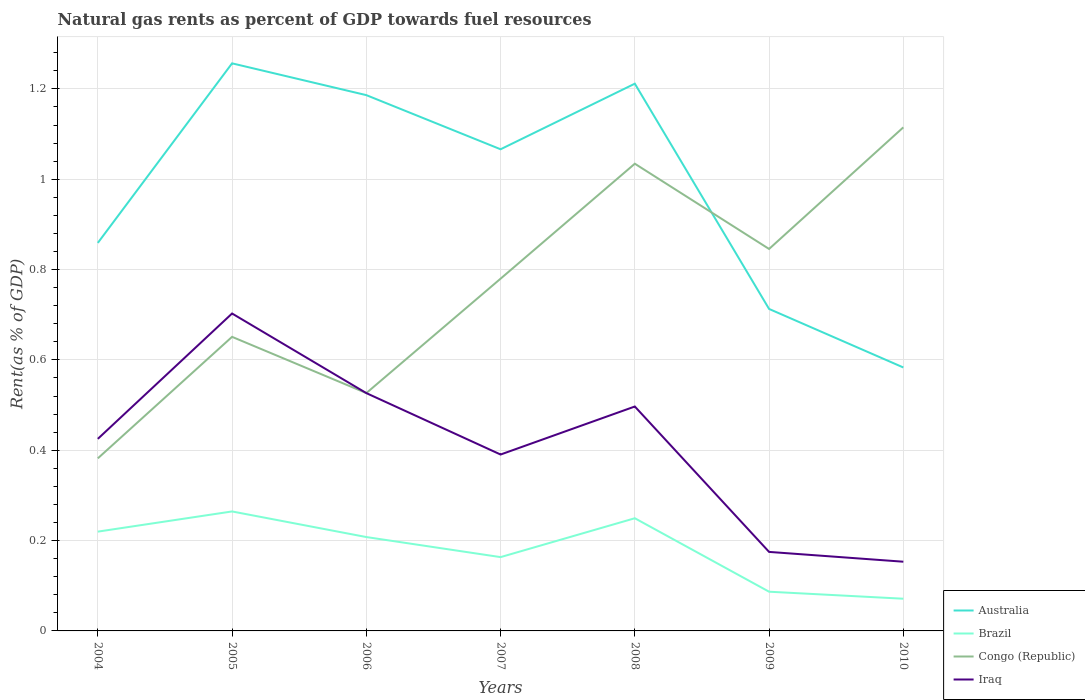Does the line corresponding to Australia intersect with the line corresponding to Congo (Republic)?
Make the answer very short. Yes. Is the number of lines equal to the number of legend labels?
Your answer should be very brief. Yes. Across all years, what is the maximum matural gas rent in Congo (Republic)?
Provide a short and direct response. 0.38. What is the total matural gas rent in Brazil in the graph?
Offer a very short reply. 0.01. What is the difference between the highest and the second highest matural gas rent in Iraq?
Your answer should be very brief. 0.55. What is the difference between the highest and the lowest matural gas rent in Congo (Republic)?
Give a very brief answer. 4. Are the values on the major ticks of Y-axis written in scientific E-notation?
Offer a very short reply. No. Does the graph contain any zero values?
Provide a short and direct response. No. Does the graph contain grids?
Make the answer very short. Yes. What is the title of the graph?
Give a very brief answer. Natural gas rents as percent of GDP towards fuel resources. Does "Liechtenstein" appear as one of the legend labels in the graph?
Make the answer very short. No. What is the label or title of the Y-axis?
Provide a succinct answer. Rent(as % of GDP). What is the Rent(as % of GDP) of Australia in 2004?
Your response must be concise. 0.86. What is the Rent(as % of GDP) in Brazil in 2004?
Keep it short and to the point. 0.22. What is the Rent(as % of GDP) of Congo (Republic) in 2004?
Offer a terse response. 0.38. What is the Rent(as % of GDP) in Iraq in 2004?
Your answer should be very brief. 0.43. What is the Rent(as % of GDP) of Australia in 2005?
Give a very brief answer. 1.26. What is the Rent(as % of GDP) of Brazil in 2005?
Provide a short and direct response. 0.26. What is the Rent(as % of GDP) of Congo (Republic) in 2005?
Give a very brief answer. 0.65. What is the Rent(as % of GDP) in Iraq in 2005?
Make the answer very short. 0.7. What is the Rent(as % of GDP) in Australia in 2006?
Give a very brief answer. 1.19. What is the Rent(as % of GDP) in Brazil in 2006?
Provide a short and direct response. 0.21. What is the Rent(as % of GDP) in Congo (Republic) in 2006?
Ensure brevity in your answer.  0.53. What is the Rent(as % of GDP) in Iraq in 2006?
Provide a succinct answer. 0.53. What is the Rent(as % of GDP) in Australia in 2007?
Provide a short and direct response. 1.07. What is the Rent(as % of GDP) in Brazil in 2007?
Give a very brief answer. 0.16. What is the Rent(as % of GDP) in Congo (Republic) in 2007?
Your answer should be very brief. 0.78. What is the Rent(as % of GDP) of Iraq in 2007?
Keep it short and to the point. 0.39. What is the Rent(as % of GDP) of Australia in 2008?
Ensure brevity in your answer.  1.21. What is the Rent(as % of GDP) in Brazil in 2008?
Offer a terse response. 0.25. What is the Rent(as % of GDP) of Congo (Republic) in 2008?
Your answer should be very brief. 1.03. What is the Rent(as % of GDP) in Iraq in 2008?
Offer a very short reply. 0.5. What is the Rent(as % of GDP) in Australia in 2009?
Your answer should be compact. 0.71. What is the Rent(as % of GDP) of Brazil in 2009?
Give a very brief answer. 0.09. What is the Rent(as % of GDP) in Congo (Republic) in 2009?
Provide a succinct answer. 0.85. What is the Rent(as % of GDP) in Iraq in 2009?
Offer a terse response. 0.17. What is the Rent(as % of GDP) of Australia in 2010?
Your response must be concise. 0.58. What is the Rent(as % of GDP) in Brazil in 2010?
Offer a very short reply. 0.07. What is the Rent(as % of GDP) of Congo (Republic) in 2010?
Keep it short and to the point. 1.11. What is the Rent(as % of GDP) in Iraq in 2010?
Ensure brevity in your answer.  0.15. Across all years, what is the maximum Rent(as % of GDP) of Australia?
Give a very brief answer. 1.26. Across all years, what is the maximum Rent(as % of GDP) of Brazil?
Your response must be concise. 0.26. Across all years, what is the maximum Rent(as % of GDP) of Congo (Republic)?
Your answer should be compact. 1.11. Across all years, what is the maximum Rent(as % of GDP) in Iraq?
Provide a succinct answer. 0.7. Across all years, what is the minimum Rent(as % of GDP) of Australia?
Keep it short and to the point. 0.58. Across all years, what is the minimum Rent(as % of GDP) of Brazil?
Offer a very short reply. 0.07. Across all years, what is the minimum Rent(as % of GDP) of Congo (Republic)?
Give a very brief answer. 0.38. Across all years, what is the minimum Rent(as % of GDP) of Iraq?
Give a very brief answer. 0.15. What is the total Rent(as % of GDP) in Australia in the graph?
Keep it short and to the point. 6.88. What is the total Rent(as % of GDP) of Brazil in the graph?
Keep it short and to the point. 1.26. What is the total Rent(as % of GDP) in Congo (Republic) in the graph?
Give a very brief answer. 5.33. What is the total Rent(as % of GDP) in Iraq in the graph?
Ensure brevity in your answer.  2.87. What is the difference between the Rent(as % of GDP) in Australia in 2004 and that in 2005?
Offer a very short reply. -0.4. What is the difference between the Rent(as % of GDP) in Brazil in 2004 and that in 2005?
Keep it short and to the point. -0.04. What is the difference between the Rent(as % of GDP) in Congo (Republic) in 2004 and that in 2005?
Keep it short and to the point. -0.27. What is the difference between the Rent(as % of GDP) in Iraq in 2004 and that in 2005?
Offer a very short reply. -0.28. What is the difference between the Rent(as % of GDP) in Australia in 2004 and that in 2006?
Provide a succinct answer. -0.33. What is the difference between the Rent(as % of GDP) of Brazil in 2004 and that in 2006?
Give a very brief answer. 0.01. What is the difference between the Rent(as % of GDP) in Congo (Republic) in 2004 and that in 2006?
Provide a succinct answer. -0.14. What is the difference between the Rent(as % of GDP) in Iraq in 2004 and that in 2006?
Keep it short and to the point. -0.1. What is the difference between the Rent(as % of GDP) of Australia in 2004 and that in 2007?
Your response must be concise. -0.21. What is the difference between the Rent(as % of GDP) in Brazil in 2004 and that in 2007?
Offer a very short reply. 0.06. What is the difference between the Rent(as % of GDP) of Congo (Republic) in 2004 and that in 2007?
Your answer should be very brief. -0.4. What is the difference between the Rent(as % of GDP) in Iraq in 2004 and that in 2007?
Ensure brevity in your answer.  0.03. What is the difference between the Rent(as % of GDP) of Australia in 2004 and that in 2008?
Give a very brief answer. -0.35. What is the difference between the Rent(as % of GDP) in Brazil in 2004 and that in 2008?
Keep it short and to the point. -0.03. What is the difference between the Rent(as % of GDP) in Congo (Republic) in 2004 and that in 2008?
Provide a succinct answer. -0.65. What is the difference between the Rent(as % of GDP) of Iraq in 2004 and that in 2008?
Provide a short and direct response. -0.07. What is the difference between the Rent(as % of GDP) in Australia in 2004 and that in 2009?
Offer a terse response. 0.15. What is the difference between the Rent(as % of GDP) in Brazil in 2004 and that in 2009?
Keep it short and to the point. 0.13. What is the difference between the Rent(as % of GDP) of Congo (Republic) in 2004 and that in 2009?
Make the answer very short. -0.46. What is the difference between the Rent(as % of GDP) of Iraq in 2004 and that in 2009?
Ensure brevity in your answer.  0.25. What is the difference between the Rent(as % of GDP) in Australia in 2004 and that in 2010?
Ensure brevity in your answer.  0.28. What is the difference between the Rent(as % of GDP) of Brazil in 2004 and that in 2010?
Provide a short and direct response. 0.15. What is the difference between the Rent(as % of GDP) of Congo (Republic) in 2004 and that in 2010?
Make the answer very short. -0.73. What is the difference between the Rent(as % of GDP) of Iraq in 2004 and that in 2010?
Provide a succinct answer. 0.27. What is the difference between the Rent(as % of GDP) of Australia in 2005 and that in 2006?
Keep it short and to the point. 0.07. What is the difference between the Rent(as % of GDP) of Brazil in 2005 and that in 2006?
Your answer should be very brief. 0.06. What is the difference between the Rent(as % of GDP) in Congo (Republic) in 2005 and that in 2006?
Provide a short and direct response. 0.12. What is the difference between the Rent(as % of GDP) in Iraq in 2005 and that in 2006?
Provide a succinct answer. 0.18. What is the difference between the Rent(as % of GDP) in Australia in 2005 and that in 2007?
Make the answer very short. 0.19. What is the difference between the Rent(as % of GDP) in Brazil in 2005 and that in 2007?
Offer a very short reply. 0.1. What is the difference between the Rent(as % of GDP) of Congo (Republic) in 2005 and that in 2007?
Offer a very short reply. -0.13. What is the difference between the Rent(as % of GDP) of Iraq in 2005 and that in 2007?
Your answer should be compact. 0.31. What is the difference between the Rent(as % of GDP) in Australia in 2005 and that in 2008?
Ensure brevity in your answer.  0.04. What is the difference between the Rent(as % of GDP) in Brazil in 2005 and that in 2008?
Keep it short and to the point. 0.01. What is the difference between the Rent(as % of GDP) in Congo (Republic) in 2005 and that in 2008?
Offer a very short reply. -0.38. What is the difference between the Rent(as % of GDP) of Iraq in 2005 and that in 2008?
Your answer should be compact. 0.21. What is the difference between the Rent(as % of GDP) in Australia in 2005 and that in 2009?
Give a very brief answer. 0.54. What is the difference between the Rent(as % of GDP) in Brazil in 2005 and that in 2009?
Make the answer very short. 0.18. What is the difference between the Rent(as % of GDP) of Congo (Republic) in 2005 and that in 2009?
Offer a terse response. -0.19. What is the difference between the Rent(as % of GDP) in Iraq in 2005 and that in 2009?
Offer a very short reply. 0.53. What is the difference between the Rent(as % of GDP) of Australia in 2005 and that in 2010?
Ensure brevity in your answer.  0.67. What is the difference between the Rent(as % of GDP) in Brazil in 2005 and that in 2010?
Your answer should be compact. 0.19. What is the difference between the Rent(as % of GDP) in Congo (Republic) in 2005 and that in 2010?
Make the answer very short. -0.46. What is the difference between the Rent(as % of GDP) in Iraq in 2005 and that in 2010?
Provide a short and direct response. 0.55. What is the difference between the Rent(as % of GDP) of Australia in 2006 and that in 2007?
Provide a short and direct response. 0.12. What is the difference between the Rent(as % of GDP) of Brazil in 2006 and that in 2007?
Your response must be concise. 0.04. What is the difference between the Rent(as % of GDP) in Congo (Republic) in 2006 and that in 2007?
Keep it short and to the point. -0.25. What is the difference between the Rent(as % of GDP) in Iraq in 2006 and that in 2007?
Your answer should be compact. 0.14. What is the difference between the Rent(as % of GDP) in Australia in 2006 and that in 2008?
Ensure brevity in your answer.  -0.03. What is the difference between the Rent(as % of GDP) of Brazil in 2006 and that in 2008?
Provide a short and direct response. -0.04. What is the difference between the Rent(as % of GDP) in Congo (Republic) in 2006 and that in 2008?
Offer a terse response. -0.51. What is the difference between the Rent(as % of GDP) of Iraq in 2006 and that in 2008?
Your response must be concise. 0.03. What is the difference between the Rent(as % of GDP) of Australia in 2006 and that in 2009?
Your response must be concise. 0.47. What is the difference between the Rent(as % of GDP) of Brazil in 2006 and that in 2009?
Offer a very short reply. 0.12. What is the difference between the Rent(as % of GDP) of Congo (Republic) in 2006 and that in 2009?
Your answer should be very brief. -0.32. What is the difference between the Rent(as % of GDP) in Iraq in 2006 and that in 2009?
Your answer should be compact. 0.35. What is the difference between the Rent(as % of GDP) in Australia in 2006 and that in 2010?
Offer a very short reply. 0.6. What is the difference between the Rent(as % of GDP) of Brazil in 2006 and that in 2010?
Offer a very short reply. 0.14. What is the difference between the Rent(as % of GDP) of Congo (Republic) in 2006 and that in 2010?
Make the answer very short. -0.59. What is the difference between the Rent(as % of GDP) of Iraq in 2006 and that in 2010?
Your answer should be compact. 0.37. What is the difference between the Rent(as % of GDP) of Australia in 2007 and that in 2008?
Keep it short and to the point. -0.15. What is the difference between the Rent(as % of GDP) in Brazil in 2007 and that in 2008?
Provide a succinct answer. -0.09. What is the difference between the Rent(as % of GDP) of Congo (Republic) in 2007 and that in 2008?
Your answer should be very brief. -0.25. What is the difference between the Rent(as % of GDP) in Iraq in 2007 and that in 2008?
Provide a succinct answer. -0.11. What is the difference between the Rent(as % of GDP) of Australia in 2007 and that in 2009?
Your answer should be very brief. 0.35. What is the difference between the Rent(as % of GDP) in Brazil in 2007 and that in 2009?
Your answer should be very brief. 0.08. What is the difference between the Rent(as % of GDP) of Congo (Republic) in 2007 and that in 2009?
Your answer should be very brief. -0.07. What is the difference between the Rent(as % of GDP) of Iraq in 2007 and that in 2009?
Your response must be concise. 0.22. What is the difference between the Rent(as % of GDP) in Australia in 2007 and that in 2010?
Keep it short and to the point. 0.48. What is the difference between the Rent(as % of GDP) in Brazil in 2007 and that in 2010?
Offer a very short reply. 0.09. What is the difference between the Rent(as % of GDP) of Congo (Republic) in 2007 and that in 2010?
Offer a very short reply. -0.34. What is the difference between the Rent(as % of GDP) of Iraq in 2007 and that in 2010?
Offer a very short reply. 0.24. What is the difference between the Rent(as % of GDP) of Australia in 2008 and that in 2009?
Your answer should be very brief. 0.5. What is the difference between the Rent(as % of GDP) of Brazil in 2008 and that in 2009?
Keep it short and to the point. 0.16. What is the difference between the Rent(as % of GDP) in Congo (Republic) in 2008 and that in 2009?
Offer a terse response. 0.19. What is the difference between the Rent(as % of GDP) of Iraq in 2008 and that in 2009?
Your response must be concise. 0.32. What is the difference between the Rent(as % of GDP) of Australia in 2008 and that in 2010?
Your answer should be compact. 0.63. What is the difference between the Rent(as % of GDP) in Brazil in 2008 and that in 2010?
Provide a short and direct response. 0.18. What is the difference between the Rent(as % of GDP) in Congo (Republic) in 2008 and that in 2010?
Offer a terse response. -0.08. What is the difference between the Rent(as % of GDP) of Iraq in 2008 and that in 2010?
Keep it short and to the point. 0.34. What is the difference between the Rent(as % of GDP) in Australia in 2009 and that in 2010?
Your answer should be compact. 0.13. What is the difference between the Rent(as % of GDP) in Brazil in 2009 and that in 2010?
Your answer should be compact. 0.02. What is the difference between the Rent(as % of GDP) of Congo (Republic) in 2009 and that in 2010?
Your response must be concise. -0.27. What is the difference between the Rent(as % of GDP) in Iraq in 2009 and that in 2010?
Your response must be concise. 0.02. What is the difference between the Rent(as % of GDP) of Australia in 2004 and the Rent(as % of GDP) of Brazil in 2005?
Your answer should be compact. 0.59. What is the difference between the Rent(as % of GDP) in Australia in 2004 and the Rent(as % of GDP) in Congo (Republic) in 2005?
Provide a succinct answer. 0.21. What is the difference between the Rent(as % of GDP) of Australia in 2004 and the Rent(as % of GDP) of Iraq in 2005?
Give a very brief answer. 0.16. What is the difference between the Rent(as % of GDP) of Brazil in 2004 and the Rent(as % of GDP) of Congo (Republic) in 2005?
Your response must be concise. -0.43. What is the difference between the Rent(as % of GDP) of Brazil in 2004 and the Rent(as % of GDP) of Iraq in 2005?
Ensure brevity in your answer.  -0.48. What is the difference between the Rent(as % of GDP) in Congo (Republic) in 2004 and the Rent(as % of GDP) in Iraq in 2005?
Offer a very short reply. -0.32. What is the difference between the Rent(as % of GDP) in Australia in 2004 and the Rent(as % of GDP) in Brazil in 2006?
Ensure brevity in your answer.  0.65. What is the difference between the Rent(as % of GDP) of Australia in 2004 and the Rent(as % of GDP) of Congo (Republic) in 2006?
Give a very brief answer. 0.33. What is the difference between the Rent(as % of GDP) in Australia in 2004 and the Rent(as % of GDP) in Iraq in 2006?
Your response must be concise. 0.33. What is the difference between the Rent(as % of GDP) of Brazil in 2004 and the Rent(as % of GDP) of Congo (Republic) in 2006?
Offer a very short reply. -0.31. What is the difference between the Rent(as % of GDP) in Brazil in 2004 and the Rent(as % of GDP) in Iraq in 2006?
Keep it short and to the point. -0.31. What is the difference between the Rent(as % of GDP) in Congo (Republic) in 2004 and the Rent(as % of GDP) in Iraq in 2006?
Offer a very short reply. -0.14. What is the difference between the Rent(as % of GDP) in Australia in 2004 and the Rent(as % of GDP) in Brazil in 2007?
Make the answer very short. 0.7. What is the difference between the Rent(as % of GDP) in Australia in 2004 and the Rent(as % of GDP) in Congo (Republic) in 2007?
Ensure brevity in your answer.  0.08. What is the difference between the Rent(as % of GDP) of Australia in 2004 and the Rent(as % of GDP) of Iraq in 2007?
Your answer should be very brief. 0.47. What is the difference between the Rent(as % of GDP) in Brazil in 2004 and the Rent(as % of GDP) in Congo (Republic) in 2007?
Give a very brief answer. -0.56. What is the difference between the Rent(as % of GDP) of Brazil in 2004 and the Rent(as % of GDP) of Iraq in 2007?
Provide a succinct answer. -0.17. What is the difference between the Rent(as % of GDP) in Congo (Republic) in 2004 and the Rent(as % of GDP) in Iraq in 2007?
Make the answer very short. -0.01. What is the difference between the Rent(as % of GDP) of Australia in 2004 and the Rent(as % of GDP) of Brazil in 2008?
Make the answer very short. 0.61. What is the difference between the Rent(as % of GDP) of Australia in 2004 and the Rent(as % of GDP) of Congo (Republic) in 2008?
Keep it short and to the point. -0.18. What is the difference between the Rent(as % of GDP) of Australia in 2004 and the Rent(as % of GDP) of Iraq in 2008?
Your answer should be compact. 0.36. What is the difference between the Rent(as % of GDP) of Brazil in 2004 and the Rent(as % of GDP) of Congo (Republic) in 2008?
Offer a very short reply. -0.81. What is the difference between the Rent(as % of GDP) of Brazil in 2004 and the Rent(as % of GDP) of Iraq in 2008?
Provide a succinct answer. -0.28. What is the difference between the Rent(as % of GDP) in Congo (Republic) in 2004 and the Rent(as % of GDP) in Iraq in 2008?
Provide a short and direct response. -0.11. What is the difference between the Rent(as % of GDP) in Australia in 2004 and the Rent(as % of GDP) in Brazil in 2009?
Your answer should be very brief. 0.77. What is the difference between the Rent(as % of GDP) in Australia in 2004 and the Rent(as % of GDP) in Congo (Republic) in 2009?
Your response must be concise. 0.01. What is the difference between the Rent(as % of GDP) in Australia in 2004 and the Rent(as % of GDP) in Iraq in 2009?
Your response must be concise. 0.68. What is the difference between the Rent(as % of GDP) of Brazil in 2004 and the Rent(as % of GDP) of Congo (Republic) in 2009?
Keep it short and to the point. -0.63. What is the difference between the Rent(as % of GDP) in Brazil in 2004 and the Rent(as % of GDP) in Iraq in 2009?
Your answer should be compact. 0.04. What is the difference between the Rent(as % of GDP) of Congo (Republic) in 2004 and the Rent(as % of GDP) of Iraq in 2009?
Make the answer very short. 0.21. What is the difference between the Rent(as % of GDP) in Australia in 2004 and the Rent(as % of GDP) in Brazil in 2010?
Provide a succinct answer. 0.79. What is the difference between the Rent(as % of GDP) in Australia in 2004 and the Rent(as % of GDP) in Congo (Republic) in 2010?
Provide a short and direct response. -0.26. What is the difference between the Rent(as % of GDP) in Australia in 2004 and the Rent(as % of GDP) in Iraq in 2010?
Make the answer very short. 0.71. What is the difference between the Rent(as % of GDP) in Brazil in 2004 and the Rent(as % of GDP) in Congo (Republic) in 2010?
Provide a short and direct response. -0.9. What is the difference between the Rent(as % of GDP) of Brazil in 2004 and the Rent(as % of GDP) of Iraq in 2010?
Make the answer very short. 0.07. What is the difference between the Rent(as % of GDP) of Congo (Republic) in 2004 and the Rent(as % of GDP) of Iraq in 2010?
Give a very brief answer. 0.23. What is the difference between the Rent(as % of GDP) in Australia in 2005 and the Rent(as % of GDP) in Brazil in 2006?
Offer a terse response. 1.05. What is the difference between the Rent(as % of GDP) of Australia in 2005 and the Rent(as % of GDP) of Congo (Republic) in 2006?
Your answer should be very brief. 0.73. What is the difference between the Rent(as % of GDP) in Australia in 2005 and the Rent(as % of GDP) in Iraq in 2006?
Provide a short and direct response. 0.73. What is the difference between the Rent(as % of GDP) in Brazil in 2005 and the Rent(as % of GDP) in Congo (Republic) in 2006?
Give a very brief answer. -0.26. What is the difference between the Rent(as % of GDP) of Brazil in 2005 and the Rent(as % of GDP) of Iraq in 2006?
Make the answer very short. -0.26. What is the difference between the Rent(as % of GDP) in Congo (Republic) in 2005 and the Rent(as % of GDP) in Iraq in 2006?
Provide a succinct answer. 0.12. What is the difference between the Rent(as % of GDP) of Australia in 2005 and the Rent(as % of GDP) of Brazil in 2007?
Your answer should be very brief. 1.09. What is the difference between the Rent(as % of GDP) of Australia in 2005 and the Rent(as % of GDP) of Congo (Republic) in 2007?
Make the answer very short. 0.48. What is the difference between the Rent(as % of GDP) in Australia in 2005 and the Rent(as % of GDP) in Iraq in 2007?
Offer a terse response. 0.87. What is the difference between the Rent(as % of GDP) of Brazil in 2005 and the Rent(as % of GDP) of Congo (Republic) in 2007?
Offer a very short reply. -0.52. What is the difference between the Rent(as % of GDP) in Brazil in 2005 and the Rent(as % of GDP) in Iraq in 2007?
Your answer should be compact. -0.13. What is the difference between the Rent(as % of GDP) of Congo (Republic) in 2005 and the Rent(as % of GDP) of Iraq in 2007?
Give a very brief answer. 0.26. What is the difference between the Rent(as % of GDP) of Australia in 2005 and the Rent(as % of GDP) of Brazil in 2008?
Provide a succinct answer. 1.01. What is the difference between the Rent(as % of GDP) in Australia in 2005 and the Rent(as % of GDP) in Congo (Republic) in 2008?
Ensure brevity in your answer.  0.22. What is the difference between the Rent(as % of GDP) in Australia in 2005 and the Rent(as % of GDP) in Iraq in 2008?
Keep it short and to the point. 0.76. What is the difference between the Rent(as % of GDP) in Brazil in 2005 and the Rent(as % of GDP) in Congo (Republic) in 2008?
Provide a succinct answer. -0.77. What is the difference between the Rent(as % of GDP) in Brazil in 2005 and the Rent(as % of GDP) in Iraq in 2008?
Give a very brief answer. -0.23. What is the difference between the Rent(as % of GDP) in Congo (Republic) in 2005 and the Rent(as % of GDP) in Iraq in 2008?
Make the answer very short. 0.15. What is the difference between the Rent(as % of GDP) of Australia in 2005 and the Rent(as % of GDP) of Brazil in 2009?
Offer a very short reply. 1.17. What is the difference between the Rent(as % of GDP) of Australia in 2005 and the Rent(as % of GDP) of Congo (Republic) in 2009?
Your answer should be very brief. 0.41. What is the difference between the Rent(as % of GDP) in Australia in 2005 and the Rent(as % of GDP) in Iraq in 2009?
Offer a very short reply. 1.08. What is the difference between the Rent(as % of GDP) of Brazil in 2005 and the Rent(as % of GDP) of Congo (Republic) in 2009?
Ensure brevity in your answer.  -0.58. What is the difference between the Rent(as % of GDP) in Brazil in 2005 and the Rent(as % of GDP) in Iraq in 2009?
Your answer should be compact. 0.09. What is the difference between the Rent(as % of GDP) of Congo (Republic) in 2005 and the Rent(as % of GDP) of Iraq in 2009?
Offer a very short reply. 0.48. What is the difference between the Rent(as % of GDP) of Australia in 2005 and the Rent(as % of GDP) of Brazil in 2010?
Ensure brevity in your answer.  1.19. What is the difference between the Rent(as % of GDP) of Australia in 2005 and the Rent(as % of GDP) of Congo (Republic) in 2010?
Provide a succinct answer. 0.14. What is the difference between the Rent(as % of GDP) in Australia in 2005 and the Rent(as % of GDP) in Iraq in 2010?
Give a very brief answer. 1.1. What is the difference between the Rent(as % of GDP) in Brazil in 2005 and the Rent(as % of GDP) in Congo (Republic) in 2010?
Keep it short and to the point. -0.85. What is the difference between the Rent(as % of GDP) of Brazil in 2005 and the Rent(as % of GDP) of Iraq in 2010?
Keep it short and to the point. 0.11. What is the difference between the Rent(as % of GDP) in Congo (Republic) in 2005 and the Rent(as % of GDP) in Iraq in 2010?
Provide a succinct answer. 0.5. What is the difference between the Rent(as % of GDP) in Australia in 2006 and the Rent(as % of GDP) in Brazil in 2007?
Your response must be concise. 1.02. What is the difference between the Rent(as % of GDP) in Australia in 2006 and the Rent(as % of GDP) in Congo (Republic) in 2007?
Offer a very short reply. 0.41. What is the difference between the Rent(as % of GDP) of Australia in 2006 and the Rent(as % of GDP) of Iraq in 2007?
Offer a very short reply. 0.8. What is the difference between the Rent(as % of GDP) of Brazil in 2006 and the Rent(as % of GDP) of Congo (Republic) in 2007?
Your answer should be very brief. -0.57. What is the difference between the Rent(as % of GDP) of Brazil in 2006 and the Rent(as % of GDP) of Iraq in 2007?
Ensure brevity in your answer.  -0.18. What is the difference between the Rent(as % of GDP) in Congo (Republic) in 2006 and the Rent(as % of GDP) in Iraq in 2007?
Offer a very short reply. 0.14. What is the difference between the Rent(as % of GDP) in Australia in 2006 and the Rent(as % of GDP) in Brazil in 2008?
Your response must be concise. 0.94. What is the difference between the Rent(as % of GDP) in Australia in 2006 and the Rent(as % of GDP) in Congo (Republic) in 2008?
Your answer should be very brief. 0.15. What is the difference between the Rent(as % of GDP) in Australia in 2006 and the Rent(as % of GDP) in Iraq in 2008?
Provide a short and direct response. 0.69. What is the difference between the Rent(as % of GDP) of Brazil in 2006 and the Rent(as % of GDP) of Congo (Republic) in 2008?
Provide a succinct answer. -0.83. What is the difference between the Rent(as % of GDP) in Brazil in 2006 and the Rent(as % of GDP) in Iraq in 2008?
Ensure brevity in your answer.  -0.29. What is the difference between the Rent(as % of GDP) in Congo (Republic) in 2006 and the Rent(as % of GDP) in Iraq in 2008?
Your answer should be compact. 0.03. What is the difference between the Rent(as % of GDP) in Australia in 2006 and the Rent(as % of GDP) in Brazil in 2009?
Offer a terse response. 1.1. What is the difference between the Rent(as % of GDP) of Australia in 2006 and the Rent(as % of GDP) of Congo (Republic) in 2009?
Ensure brevity in your answer.  0.34. What is the difference between the Rent(as % of GDP) of Australia in 2006 and the Rent(as % of GDP) of Iraq in 2009?
Give a very brief answer. 1.01. What is the difference between the Rent(as % of GDP) of Brazil in 2006 and the Rent(as % of GDP) of Congo (Republic) in 2009?
Your response must be concise. -0.64. What is the difference between the Rent(as % of GDP) in Brazil in 2006 and the Rent(as % of GDP) in Iraq in 2009?
Your answer should be compact. 0.03. What is the difference between the Rent(as % of GDP) in Congo (Republic) in 2006 and the Rent(as % of GDP) in Iraq in 2009?
Your response must be concise. 0.35. What is the difference between the Rent(as % of GDP) of Australia in 2006 and the Rent(as % of GDP) of Brazil in 2010?
Offer a very short reply. 1.11. What is the difference between the Rent(as % of GDP) in Australia in 2006 and the Rent(as % of GDP) in Congo (Republic) in 2010?
Give a very brief answer. 0.07. What is the difference between the Rent(as % of GDP) of Australia in 2006 and the Rent(as % of GDP) of Iraq in 2010?
Keep it short and to the point. 1.03. What is the difference between the Rent(as % of GDP) in Brazil in 2006 and the Rent(as % of GDP) in Congo (Republic) in 2010?
Give a very brief answer. -0.91. What is the difference between the Rent(as % of GDP) of Brazil in 2006 and the Rent(as % of GDP) of Iraq in 2010?
Make the answer very short. 0.05. What is the difference between the Rent(as % of GDP) in Congo (Republic) in 2006 and the Rent(as % of GDP) in Iraq in 2010?
Give a very brief answer. 0.37. What is the difference between the Rent(as % of GDP) in Australia in 2007 and the Rent(as % of GDP) in Brazil in 2008?
Offer a terse response. 0.82. What is the difference between the Rent(as % of GDP) in Australia in 2007 and the Rent(as % of GDP) in Congo (Republic) in 2008?
Your response must be concise. 0.03. What is the difference between the Rent(as % of GDP) of Australia in 2007 and the Rent(as % of GDP) of Iraq in 2008?
Your answer should be very brief. 0.57. What is the difference between the Rent(as % of GDP) in Brazil in 2007 and the Rent(as % of GDP) in Congo (Republic) in 2008?
Offer a very short reply. -0.87. What is the difference between the Rent(as % of GDP) of Brazil in 2007 and the Rent(as % of GDP) of Iraq in 2008?
Keep it short and to the point. -0.33. What is the difference between the Rent(as % of GDP) in Congo (Republic) in 2007 and the Rent(as % of GDP) in Iraq in 2008?
Ensure brevity in your answer.  0.28. What is the difference between the Rent(as % of GDP) in Australia in 2007 and the Rent(as % of GDP) in Brazil in 2009?
Give a very brief answer. 0.98. What is the difference between the Rent(as % of GDP) in Australia in 2007 and the Rent(as % of GDP) in Congo (Republic) in 2009?
Give a very brief answer. 0.22. What is the difference between the Rent(as % of GDP) in Australia in 2007 and the Rent(as % of GDP) in Iraq in 2009?
Make the answer very short. 0.89. What is the difference between the Rent(as % of GDP) in Brazil in 2007 and the Rent(as % of GDP) in Congo (Republic) in 2009?
Make the answer very short. -0.68. What is the difference between the Rent(as % of GDP) in Brazil in 2007 and the Rent(as % of GDP) in Iraq in 2009?
Make the answer very short. -0.01. What is the difference between the Rent(as % of GDP) in Congo (Republic) in 2007 and the Rent(as % of GDP) in Iraq in 2009?
Offer a very short reply. 0.6. What is the difference between the Rent(as % of GDP) of Australia in 2007 and the Rent(as % of GDP) of Brazil in 2010?
Ensure brevity in your answer.  1. What is the difference between the Rent(as % of GDP) of Australia in 2007 and the Rent(as % of GDP) of Congo (Republic) in 2010?
Give a very brief answer. -0.05. What is the difference between the Rent(as % of GDP) in Australia in 2007 and the Rent(as % of GDP) in Iraq in 2010?
Provide a succinct answer. 0.91. What is the difference between the Rent(as % of GDP) of Brazil in 2007 and the Rent(as % of GDP) of Congo (Republic) in 2010?
Ensure brevity in your answer.  -0.95. What is the difference between the Rent(as % of GDP) of Brazil in 2007 and the Rent(as % of GDP) of Iraq in 2010?
Provide a succinct answer. 0.01. What is the difference between the Rent(as % of GDP) in Congo (Republic) in 2007 and the Rent(as % of GDP) in Iraq in 2010?
Keep it short and to the point. 0.63. What is the difference between the Rent(as % of GDP) in Australia in 2008 and the Rent(as % of GDP) in Brazil in 2009?
Ensure brevity in your answer.  1.12. What is the difference between the Rent(as % of GDP) in Australia in 2008 and the Rent(as % of GDP) in Congo (Republic) in 2009?
Keep it short and to the point. 0.37. What is the difference between the Rent(as % of GDP) of Australia in 2008 and the Rent(as % of GDP) of Iraq in 2009?
Make the answer very short. 1.04. What is the difference between the Rent(as % of GDP) in Brazil in 2008 and the Rent(as % of GDP) in Congo (Republic) in 2009?
Your answer should be very brief. -0.6. What is the difference between the Rent(as % of GDP) of Brazil in 2008 and the Rent(as % of GDP) of Iraq in 2009?
Ensure brevity in your answer.  0.07. What is the difference between the Rent(as % of GDP) in Congo (Republic) in 2008 and the Rent(as % of GDP) in Iraq in 2009?
Your answer should be very brief. 0.86. What is the difference between the Rent(as % of GDP) of Australia in 2008 and the Rent(as % of GDP) of Brazil in 2010?
Your response must be concise. 1.14. What is the difference between the Rent(as % of GDP) of Australia in 2008 and the Rent(as % of GDP) of Congo (Republic) in 2010?
Your answer should be compact. 0.1. What is the difference between the Rent(as % of GDP) of Australia in 2008 and the Rent(as % of GDP) of Iraq in 2010?
Make the answer very short. 1.06. What is the difference between the Rent(as % of GDP) of Brazil in 2008 and the Rent(as % of GDP) of Congo (Republic) in 2010?
Make the answer very short. -0.87. What is the difference between the Rent(as % of GDP) in Brazil in 2008 and the Rent(as % of GDP) in Iraq in 2010?
Offer a very short reply. 0.1. What is the difference between the Rent(as % of GDP) in Congo (Republic) in 2008 and the Rent(as % of GDP) in Iraq in 2010?
Your response must be concise. 0.88. What is the difference between the Rent(as % of GDP) in Australia in 2009 and the Rent(as % of GDP) in Brazil in 2010?
Ensure brevity in your answer.  0.64. What is the difference between the Rent(as % of GDP) of Australia in 2009 and the Rent(as % of GDP) of Congo (Republic) in 2010?
Your answer should be very brief. -0.4. What is the difference between the Rent(as % of GDP) in Australia in 2009 and the Rent(as % of GDP) in Iraq in 2010?
Ensure brevity in your answer.  0.56. What is the difference between the Rent(as % of GDP) in Brazil in 2009 and the Rent(as % of GDP) in Congo (Republic) in 2010?
Provide a succinct answer. -1.03. What is the difference between the Rent(as % of GDP) in Brazil in 2009 and the Rent(as % of GDP) in Iraq in 2010?
Provide a succinct answer. -0.07. What is the difference between the Rent(as % of GDP) in Congo (Republic) in 2009 and the Rent(as % of GDP) in Iraq in 2010?
Provide a succinct answer. 0.69. What is the average Rent(as % of GDP) in Australia per year?
Keep it short and to the point. 0.98. What is the average Rent(as % of GDP) of Brazil per year?
Your answer should be compact. 0.18. What is the average Rent(as % of GDP) of Congo (Republic) per year?
Offer a very short reply. 0.76. What is the average Rent(as % of GDP) of Iraq per year?
Make the answer very short. 0.41. In the year 2004, what is the difference between the Rent(as % of GDP) in Australia and Rent(as % of GDP) in Brazil?
Ensure brevity in your answer.  0.64. In the year 2004, what is the difference between the Rent(as % of GDP) in Australia and Rent(as % of GDP) in Congo (Republic)?
Your answer should be compact. 0.48. In the year 2004, what is the difference between the Rent(as % of GDP) of Australia and Rent(as % of GDP) of Iraq?
Keep it short and to the point. 0.43. In the year 2004, what is the difference between the Rent(as % of GDP) in Brazil and Rent(as % of GDP) in Congo (Republic)?
Provide a succinct answer. -0.16. In the year 2004, what is the difference between the Rent(as % of GDP) of Brazil and Rent(as % of GDP) of Iraq?
Ensure brevity in your answer.  -0.21. In the year 2004, what is the difference between the Rent(as % of GDP) of Congo (Republic) and Rent(as % of GDP) of Iraq?
Your answer should be compact. -0.04. In the year 2005, what is the difference between the Rent(as % of GDP) in Australia and Rent(as % of GDP) in Congo (Republic)?
Make the answer very short. 0.61. In the year 2005, what is the difference between the Rent(as % of GDP) of Australia and Rent(as % of GDP) of Iraq?
Keep it short and to the point. 0.55. In the year 2005, what is the difference between the Rent(as % of GDP) of Brazil and Rent(as % of GDP) of Congo (Republic)?
Your answer should be compact. -0.39. In the year 2005, what is the difference between the Rent(as % of GDP) in Brazil and Rent(as % of GDP) in Iraq?
Ensure brevity in your answer.  -0.44. In the year 2005, what is the difference between the Rent(as % of GDP) of Congo (Republic) and Rent(as % of GDP) of Iraq?
Provide a short and direct response. -0.05. In the year 2006, what is the difference between the Rent(as % of GDP) of Australia and Rent(as % of GDP) of Brazil?
Your response must be concise. 0.98. In the year 2006, what is the difference between the Rent(as % of GDP) in Australia and Rent(as % of GDP) in Congo (Republic)?
Your answer should be compact. 0.66. In the year 2006, what is the difference between the Rent(as % of GDP) of Australia and Rent(as % of GDP) of Iraq?
Your answer should be very brief. 0.66. In the year 2006, what is the difference between the Rent(as % of GDP) of Brazil and Rent(as % of GDP) of Congo (Republic)?
Make the answer very short. -0.32. In the year 2006, what is the difference between the Rent(as % of GDP) of Brazil and Rent(as % of GDP) of Iraq?
Make the answer very short. -0.32. In the year 2007, what is the difference between the Rent(as % of GDP) in Australia and Rent(as % of GDP) in Brazil?
Ensure brevity in your answer.  0.9. In the year 2007, what is the difference between the Rent(as % of GDP) in Australia and Rent(as % of GDP) in Congo (Republic)?
Make the answer very short. 0.29. In the year 2007, what is the difference between the Rent(as % of GDP) of Australia and Rent(as % of GDP) of Iraq?
Your answer should be very brief. 0.68. In the year 2007, what is the difference between the Rent(as % of GDP) of Brazil and Rent(as % of GDP) of Congo (Republic)?
Offer a terse response. -0.62. In the year 2007, what is the difference between the Rent(as % of GDP) of Brazil and Rent(as % of GDP) of Iraq?
Your answer should be very brief. -0.23. In the year 2007, what is the difference between the Rent(as % of GDP) in Congo (Republic) and Rent(as % of GDP) in Iraq?
Give a very brief answer. 0.39. In the year 2008, what is the difference between the Rent(as % of GDP) in Australia and Rent(as % of GDP) in Brazil?
Keep it short and to the point. 0.96. In the year 2008, what is the difference between the Rent(as % of GDP) of Australia and Rent(as % of GDP) of Congo (Republic)?
Provide a succinct answer. 0.18. In the year 2008, what is the difference between the Rent(as % of GDP) in Australia and Rent(as % of GDP) in Iraq?
Ensure brevity in your answer.  0.71. In the year 2008, what is the difference between the Rent(as % of GDP) in Brazil and Rent(as % of GDP) in Congo (Republic)?
Ensure brevity in your answer.  -0.78. In the year 2008, what is the difference between the Rent(as % of GDP) in Brazil and Rent(as % of GDP) in Iraq?
Provide a short and direct response. -0.25. In the year 2008, what is the difference between the Rent(as % of GDP) in Congo (Republic) and Rent(as % of GDP) in Iraq?
Offer a very short reply. 0.54. In the year 2009, what is the difference between the Rent(as % of GDP) of Australia and Rent(as % of GDP) of Brazil?
Keep it short and to the point. 0.63. In the year 2009, what is the difference between the Rent(as % of GDP) of Australia and Rent(as % of GDP) of Congo (Republic)?
Make the answer very short. -0.13. In the year 2009, what is the difference between the Rent(as % of GDP) of Australia and Rent(as % of GDP) of Iraq?
Provide a succinct answer. 0.54. In the year 2009, what is the difference between the Rent(as % of GDP) in Brazil and Rent(as % of GDP) in Congo (Republic)?
Offer a terse response. -0.76. In the year 2009, what is the difference between the Rent(as % of GDP) of Brazil and Rent(as % of GDP) of Iraq?
Ensure brevity in your answer.  -0.09. In the year 2009, what is the difference between the Rent(as % of GDP) in Congo (Republic) and Rent(as % of GDP) in Iraq?
Give a very brief answer. 0.67. In the year 2010, what is the difference between the Rent(as % of GDP) of Australia and Rent(as % of GDP) of Brazil?
Your answer should be very brief. 0.51. In the year 2010, what is the difference between the Rent(as % of GDP) in Australia and Rent(as % of GDP) in Congo (Republic)?
Ensure brevity in your answer.  -0.53. In the year 2010, what is the difference between the Rent(as % of GDP) of Australia and Rent(as % of GDP) of Iraq?
Your response must be concise. 0.43. In the year 2010, what is the difference between the Rent(as % of GDP) in Brazil and Rent(as % of GDP) in Congo (Republic)?
Ensure brevity in your answer.  -1.04. In the year 2010, what is the difference between the Rent(as % of GDP) of Brazil and Rent(as % of GDP) of Iraq?
Offer a very short reply. -0.08. In the year 2010, what is the difference between the Rent(as % of GDP) of Congo (Republic) and Rent(as % of GDP) of Iraq?
Offer a very short reply. 0.96. What is the ratio of the Rent(as % of GDP) of Australia in 2004 to that in 2005?
Make the answer very short. 0.68. What is the ratio of the Rent(as % of GDP) of Brazil in 2004 to that in 2005?
Your response must be concise. 0.83. What is the ratio of the Rent(as % of GDP) in Congo (Republic) in 2004 to that in 2005?
Give a very brief answer. 0.59. What is the ratio of the Rent(as % of GDP) in Iraq in 2004 to that in 2005?
Your response must be concise. 0.61. What is the ratio of the Rent(as % of GDP) in Australia in 2004 to that in 2006?
Give a very brief answer. 0.72. What is the ratio of the Rent(as % of GDP) of Brazil in 2004 to that in 2006?
Your answer should be compact. 1.06. What is the ratio of the Rent(as % of GDP) of Congo (Republic) in 2004 to that in 2006?
Offer a terse response. 0.73. What is the ratio of the Rent(as % of GDP) of Iraq in 2004 to that in 2006?
Your response must be concise. 0.81. What is the ratio of the Rent(as % of GDP) in Australia in 2004 to that in 2007?
Keep it short and to the point. 0.81. What is the ratio of the Rent(as % of GDP) in Brazil in 2004 to that in 2007?
Your response must be concise. 1.35. What is the ratio of the Rent(as % of GDP) of Congo (Republic) in 2004 to that in 2007?
Provide a short and direct response. 0.49. What is the ratio of the Rent(as % of GDP) of Iraq in 2004 to that in 2007?
Provide a succinct answer. 1.09. What is the ratio of the Rent(as % of GDP) of Australia in 2004 to that in 2008?
Offer a terse response. 0.71. What is the ratio of the Rent(as % of GDP) of Brazil in 2004 to that in 2008?
Offer a terse response. 0.88. What is the ratio of the Rent(as % of GDP) in Congo (Republic) in 2004 to that in 2008?
Keep it short and to the point. 0.37. What is the ratio of the Rent(as % of GDP) in Iraq in 2004 to that in 2008?
Your response must be concise. 0.86. What is the ratio of the Rent(as % of GDP) of Australia in 2004 to that in 2009?
Make the answer very short. 1.21. What is the ratio of the Rent(as % of GDP) of Brazil in 2004 to that in 2009?
Make the answer very short. 2.53. What is the ratio of the Rent(as % of GDP) in Congo (Republic) in 2004 to that in 2009?
Offer a terse response. 0.45. What is the ratio of the Rent(as % of GDP) in Iraq in 2004 to that in 2009?
Make the answer very short. 2.43. What is the ratio of the Rent(as % of GDP) of Australia in 2004 to that in 2010?
Provide a succinct answer. 1.47. What is the ratio of the Rent(as % of GDP) of Brazil in 2004 to that in 2010?
Give a very brief answer. 3.08. What is the ratio of the Rent(as % of GDP) in Congo (Republic) in 2004 to that in 2010?
Keep it short and to the point. 0.34. What is the ratio of the Rent(as % of GDP) in Iraq in 2004 to that in 2010?
Provide a short and direct response. 2.77. What is the ratio of the Rent(as % of GDP) in Australia in 2005 to that in 2006?
Make the answer very short. 1.06. What is the ratio of the Rent(as % of GDP) in Brazil in 2005 to that in 2006?
Your response must be concise. 1.27. What is the ratio of the Rent(as % of GDP) in Congo (Republic) in 2005 to that in 2006?
Offer a terse response. 1.24. What is the ratio of the Rent(as % of GDP) in Iraq in 2005 to that in 2006?
Your answer should be compact. 1.33. What is the ratio of the Rent(as % of GDP) in Australia in 2005 to that in 2007?
Your response must be concise. 1.18. What is the ratio of the Rent(as % of GDP) of Brazil in 2005 to that in 2007?
Give a very brief answer. 1.62. What is the ratio of the Rent(as % of GDP) in Congo (Republic) in 2005 to that in 2007?
Offer a very short reply. 0.83. What is the ratio of the Rent(as % of GDP) in Iraq in 2005 to that in 2007?
Your answer should be very brief. 1.8. What is the ratio of the Rent(as % of GDP) of Australia in 2005 to that in 2008?
Your response must be concise. 1.04. What is the ratio of the Rent(as % of GDP) in Brazil in 2005 to that in 2008?
Your answer should be very brief. 1.06. What is the ratio of the Rent(as % of GDP) in Congo (Republic) in 2005 to that in 2008?
Keep it short and to the point. 0.63. What is the ratio of the Rent(as % of GDP) in Iraq in 2005 to that in 2008?
Make the answer very short. 1.41. What is the ratio of the Rent(as % of GDP) in Australia in 2005 to that in 2009?
Ensure brevity in your answer.  1.76. What is the ratio of the Rent(as % of GDP) of Brazil in 2005 to that in 2009?
Provide a short and direct response. 3.05. What is the ratio of the Rent(as % of GDP) of Congo (Republic) in 2005 to that in 2009?
Keep it short and to the point. 0.77. What is the ratio of the Rent(as % of GDP) of Iraq in 2005 to that in 2009?
Ensure brevity in your answer.  4.02. What is the ratio of the Rent(as % of GDP) in Australia in 2005 to that in 2010?
Keep it short and to the point. 2.15. What is the ratio of the Rent(as % of GDP) in Brazil in 2005 to that in 2010?
Offer a very short reply. 3.71. What is the ratio of the Rent(as % of GDP) in Congo (Republic) in 2005 to that in 2010?
Offer a terse response. 0.58. What is the ratio of the Rent(as % of GDP) in Iraq in 2005 to that in 2010?
Offer a terse response. 4.59. What is the ratio of the Rent(as % of GDP) of Australia in 2006 to that in 2007?
Provide a short and direct response. 1.11. What is the ratio of the Rent(as % of GDP) of Brazil in 2006 to that in 2007?
Your response must be concise. 1.27. What is the ratio of the Rent(as % of GDP) of Congo (Republic) in 2006 to that in 2007?
Provide a short and direct response. 0.68. What is the ratio of the Rent(as % of GDP) in Iraq in 2006 to that in 2007?
Offer a very short reply. 1.35. What is the ratio of the Rent(as % of GDP) of Australia in 2006 to that in 2008?
Ensure brevity in your answer.  0.98. What is the ratio of the Rent(as % of GDP) of Brazil in 2006 to that in 2008?
Offer a very short reply. 0.83. What is the ratio of the Rent(as % of GDP) in Congo (Republic) in 2006 to that in 2008?
Provide a succinct answer. 0.51. What is the ratio of the Rent(as % of GDP) of Iraq in 2006 to that in 2008?
Keep it short and to the point. 1.06. What is the ratio of the Rent(as % of GDP) in Australia in 2006 to that in 2009?
Your answer should be very brief. 1.66. What is the ratio of the Rent(as % of GDP) in Brazil in 2006 to that in 2009?
Ensure brevity in your answer.  2.39. What is the ratio of the Rent(as % of GDP) of Congo (Republic) in 2006 to that in 2009?
Keep it short and to the point. 0.62. What is the ratio of the Rent(as % of GDP) in Iraq in 2006 to that in 2009?
Keep it short and to the point. 3.01. What is the ratio of the Rent(as % of GDP) of Australia in 2006 to that in 2010?
Keep it short and to the point. 2.03. What is the ratio of the Rent(as % of GDP) in Brazil in 2006 to that in 2010?
Provide a succinct answer. 2.92. What is the ratio of the Rent(as % of GDP) in Congo (Republic) in 2006 to that in 2010?
Provide a succinct answer. 0.47. What is the ratio of the Rent(as % of GDP) of Iraq in 2006 to that in 2010?
Your answer should be very brief. 3.44. What is the ratio of the Rent(as % of GDP) of Australia in 2007 to that in 2008?
Offer a very short reply. 0.88. What is the ratio of the Rent(as % of GDP) in Brazil in 2007 to that in 2008?
Give a very brief answer. 0.66. What is the ratio of the Rent(as % of GDP) in Congo (Republic) in 2007 to that in 2008?
Your answer should be very brief. 0.75. What is the ratio of the Rent(as % of GDP) of Iraq in 2007 to that in 2008?
Offer a very short reply. 0.79. What is the ratio of the Rent(as % of GDP) in Australia in 2007 to that in 2009?
Provide a short and direct response. 1.5. What is the ratio of the Rent(as % of GDP) of Brazil in 2007 to that in 2009?
Offer a very short reply. 1.88. What is the ratio of the Rent(as % of GDP) of Congo (Republic) in 2007 to that in 2009?
Make the answer very short. 0.92. What is the ratio of the Rent(as % of GDP) of Iraq in 2007 to that in 2009?
Make the answer very short. 2.23. What is the ratio of the Rent(as % of GDP) in Australia in 2007 to that in 2010?
Offer a very short reply. 1.83. What is the ratio of the Rent(as % of GDP) in Brazil in 2007 to that in 2010?
Keep it short and to the point. 2.29. What is the ratio of the Rent(as % of GDP) of Congo (Republic) in 2007 to that in 2010?
Your answer should be compact. 0.7. What is the ratio of the Rent(as % of GDP) in Iraq in 2007 to that in 2010?
Provide a short and direct response. 2.55. What is the ratio of the Rent(as % of GDP) of Australia in 2008 to that in 2009?
Make the answer very short. 1.7. What is the ratio of the Rent(as % of GDP) in Brazil in 2008 to that in 2009?
Ensure brevity in your answer.  2.87. What is the ratio of the Rent(as % of GDP) of Congo (Republic) in 2008 to that in 2009?
Provide a succinct answer. 1.22. What is the ratio of the Rent(as % of GDP) of Iraq in 2008 to that in 2009?
Ensure brevity in your answer.  2.84. What is the ratio of the Rent(as % of GDP) of Australia in 2008 to that in 2010?
Provide a succinct answer. 2.08. What is the ratio of the Rent(as % of GDP) in Brazil in 2008 to that in 2010?
Make the answer very short. 3.5. What is the ratio of the Rent(as % of GDP) in Congo (Republic) in 2008 to that in 2010?
Provide a succinct answer. 0.93. What is the ratio of the Rent(as % of GDP) of Iraq in 2008 to that in 2010?
Offer a very short reply. 3.24. What is the ratio of the Rent(as % of GDP) of Australia in 2009 to that in 2010?
Provide a succinct answer. 1.22. What is the ratio of the Rent(as % of GDP) of Brazil in 2009 to that in 2010?
Your answer should be compact. 1.22. What is the ratio of the Rent(as % of GDP) of Congo (Republic) in 2009 to that in 2010?
Ensure brevity in your answer.  0.76. What is the ratio of the Rent(as % of GDP) of Iraq in 2009 to that in 2010?
Your response must be concise. 1.14. What is the difference between the highest and the second highest Rent(as % of GDP) in Australia?
Your answer should be compact. 0.04. What is the difference between the highest and the second highest Rent(as % of GDP) in Brazil?
Ensure brevity in your answer.  0.01. What is the difference between the highest and the second highest Rent(as % of GDP) of Congo (Republic)?
Make the answer very short. 0.08. What is the difference between the highest and the second highest Rent(as % of GDP) of Iraq?
Provide a succinct answer. 0.18. What is the difference between the highest and the lowest Rent(as % of GDP) in Australia?
Provide a succinct answer. 0.67. What is the difference between the highest and the lowest Rent(as % of GDP) of Brazil?
Your response must be concise. 0.19. What is the difference between the highest and the lowest Rent(as % of GDP) in Congo (Republic)?
Keep it short and to the point. 0.73. What is the difference between the highest and the lowest Rent(as % of GDP) of Iraq?
Your answer should be compact. 0.55. 